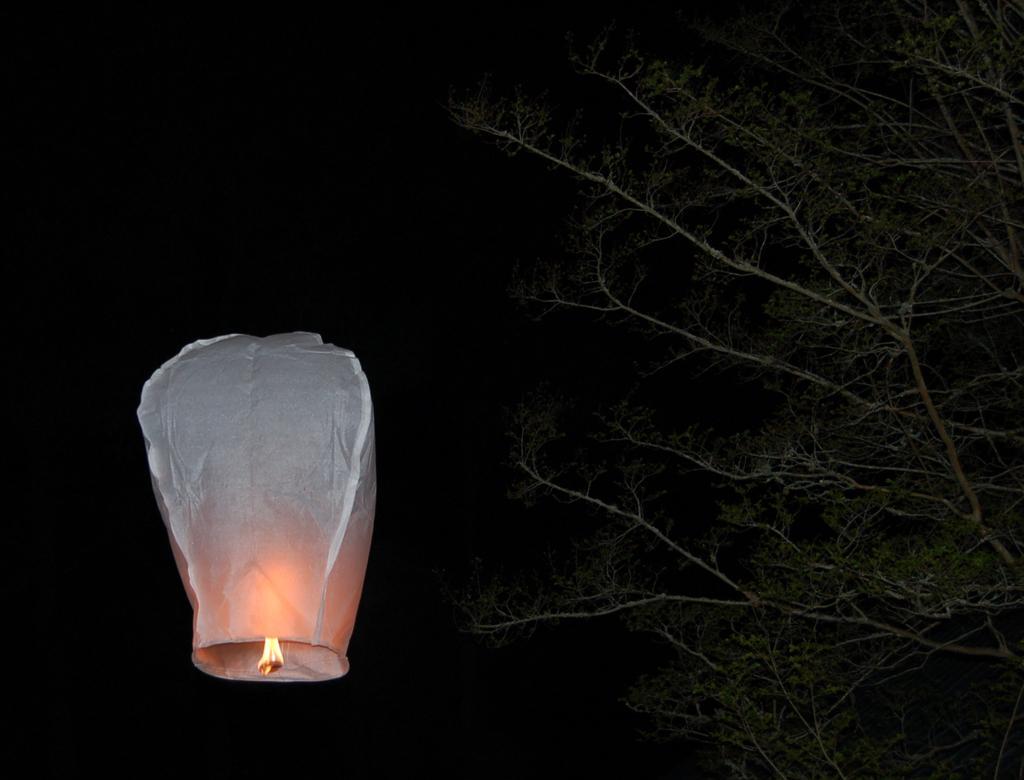How would you summarize this image in a sentence or two? In this picture we can see a lantern in the air, trees and in the background it is dark. 